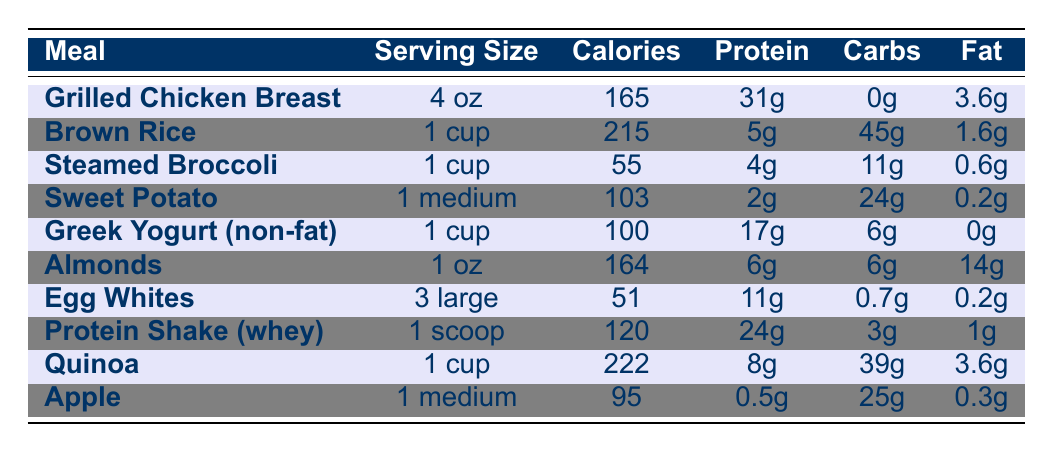What is the calorie count for Grilled Chicken Breast? The table lists the calorie count for Grilled Chicken Breast as 165 calories in the corresponding row.
Answer: 165 calories How much protein is in a serving of Greek Yogurt (non-fat)? The table shows that Greek Yogurt (non-fat) contains 17g of protein, which is found in the row for Greek Yogurt.
Answer: 17g Which meal has the highest fat content? By examining the Fat column, Almonds have the highest fat content at 14g. Comparing values from all meals confirms this.
Answer: Almonds What is the combined calorie count of Brown Rice and Quinoa? The calorie count for Brown Rice is 215 calories and for Quinoa is 222 calories. Adding these gives 215 + 222 = 437 calories as the total.
Answer: 437 calories Is the protein content of Sweet Potato greater than that of Egg Whites? The protein content of Sweet Potato is 2g while Egg Whites contain 11g, therefore, the statement is false as 2g is less than 11g.
Answer: No What is the total carbohydrate content if I consume 1 cup of Brown Rice and 1 medium Apple? The carbohydrate content for Brown Rice is 45g and for Apple it is 25g. Adding these values gives 45 + 25 = 70g.
Answer: 70g Which meal has the lowest calorie content? Looking through the Calories column, Steamed Broccoli has the lowest calorie content, listed at 55 calories, which makes it the meal with the least calories.
Answer: Steamed Broccoli What is the average protein content of the meals listed in the table? The protein contents from the table are: 31g, 5g, 4g, 2g, 17g, 6g, 11g, 24g, 8g, 0.5g. Summing these gives 109.5g. There are 10 meals, so the average protein is 109.5/10 = 10.95g.
Answer: 10.95g Is there any meal that contains more than 200 calories? Based on the Calories column, both Brown Rice (215 calories) and Quinoa (222 calories) exceed 200 calories, confirming that the answer is yes.
Answer: Yes 